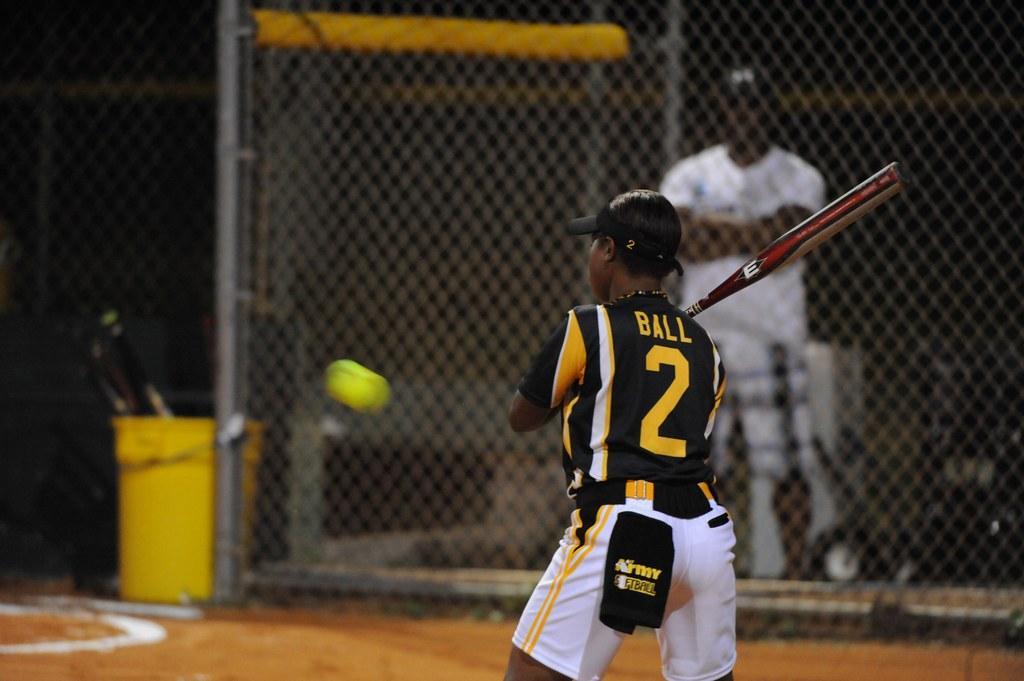<image>
Offer a succinct explanation of the picture presented. A batter named Ball playing in a baseball game. 